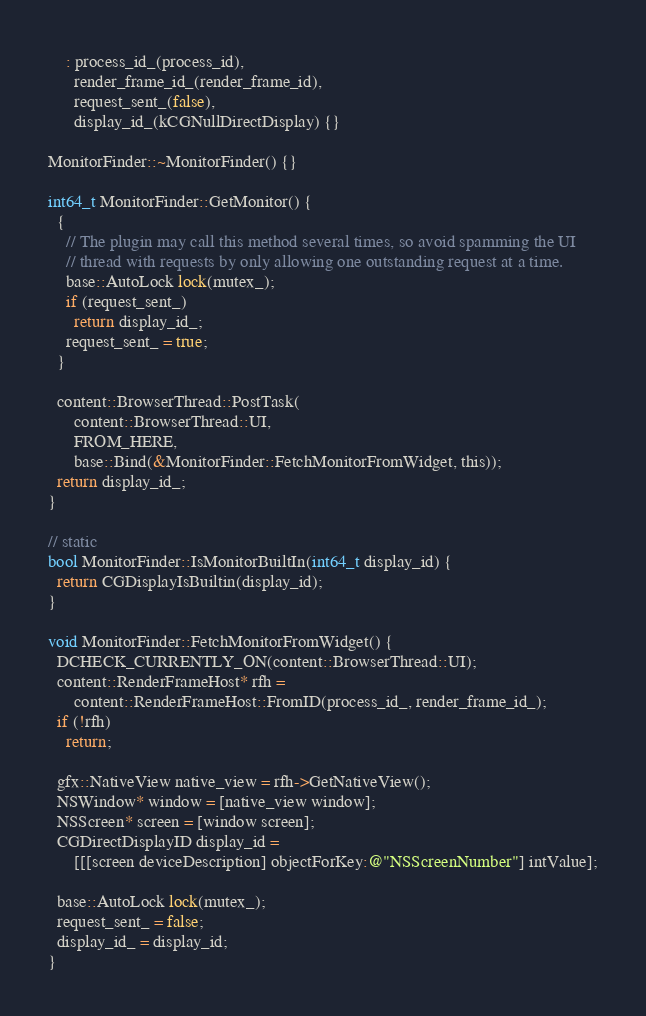Convert code to text. <code><loc_0><loc_0><loc_500><loc_500><_ObjectiveC_>    : process_id_(process_id),
      render_frame_id_(render_frame_id),
      request_sent_(false),
      display_id_(kCGNullDirectDisplay) {}

MonitorFinder::~MonitorFinder() {}

int64_t MonitorFinder::GetMonitor() {
  {
    // The plugin may call this method several times, so avoid spamming the UI
    // thread with requests by only allowing one outstanding request at a time.
    base::AutoLock lock(mutex_);
    if (request_sent_)
      return display_id_;
    request_sent_ = true;
  }

  content::BrowserThread::PostTask(
      content::BrowserThread::UI,
      FROM_HERE,
      base::Bind(&MonitorFinder::FetchMonitorFromWidget, this));
  return display_id_;
}

// static
bool MonitorFinder::IsMonitorBuiltIn(int64_t display_id) {
  return CGDisplayIsBuiltin(display_id);
}

void MonitorFinder::FetchMonitorFromWidget() {
  DCHECK_CURRENTLY_ON(content::BrowserThread::UI);
  content::RenderFrameHost* rfh =
      content::RenderFrameHost::FromID(process_id_, render_frame_id_);
  if (!rfh)
    return;

  gfx::NativeView native_view = rfh->GetNativeView();
  NSWindow* window = [native_view window];
  NSScreen* screen = [window screen];
  CGDirectDisplayID display_id =
      [[[screen deviceDescription] objectForKey:@"NSScreenNumber"] intValue];

  base::AutoLock lock(mutex_);
  request_sent_ = false;
  display_id_ = display_id;
}
</code> 